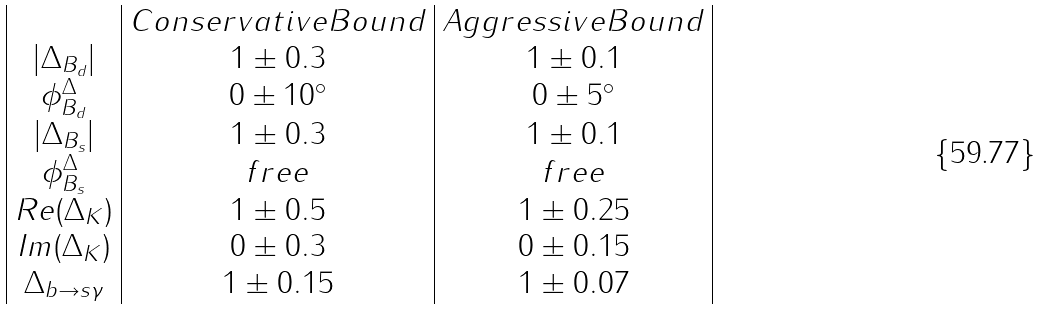<formula> <loc_0><loc_0><loc_500><loc_500>\begin{array} { | c | c | c | } & C o n s e r v a t i v e B o u n d & A g g r e s s i v e B o u n d \\ | \Delta _ { B _ { d } } | & 1 \pm 0 . 3 & 1 \pm 0 . 1 \\ \phi ^ { \Delta } _ { B _ { d } } & 0 \pm 1 0 ^ { \circ } & 0 \pm 5 ^ { \circ } \\ | \Delta _ { B _ { s } } | & 1 \pm 0 . 3 & 1 \pm 0 . 1 \\ \phi ^ { \Delta } _ { B _ { s } } & f r e e & f r e e \\ R e ( \Delta _ { K } ) & 1 \pm 0 . 5 & 1 \pm 0 . 2 5 \\ I m ( \Delta _ { K } ) & 0 \pm 0 . 3 & 0 \pm 0 . 1 5 \\ \Delta _ { b \to s \gamma } & 1 \pm 0 . 1 5 & 1 \pm 0 . 0 7 \\ \end{array}</formula> 